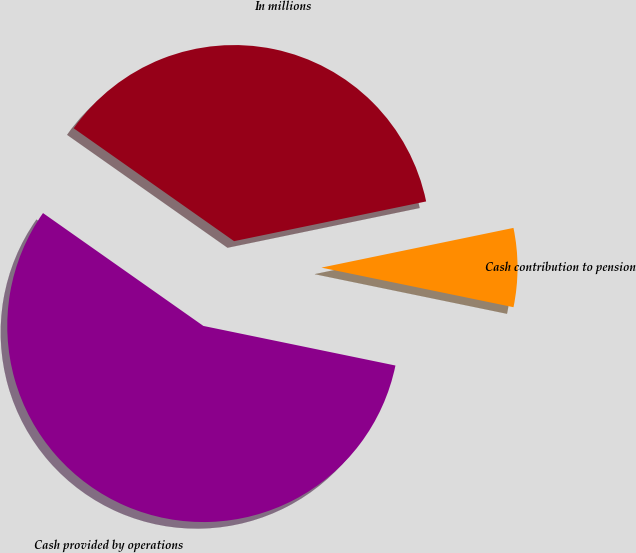<chart> <loc_0><loc_0><loc_500><loc_500><pie_chart><fcel>In millions<fcel>Cash provided by operations<fcel>Cash contribution to pension<nl><fcel>36.99%<fcel>56.52%<fcel>6.48%<nl></chart> 